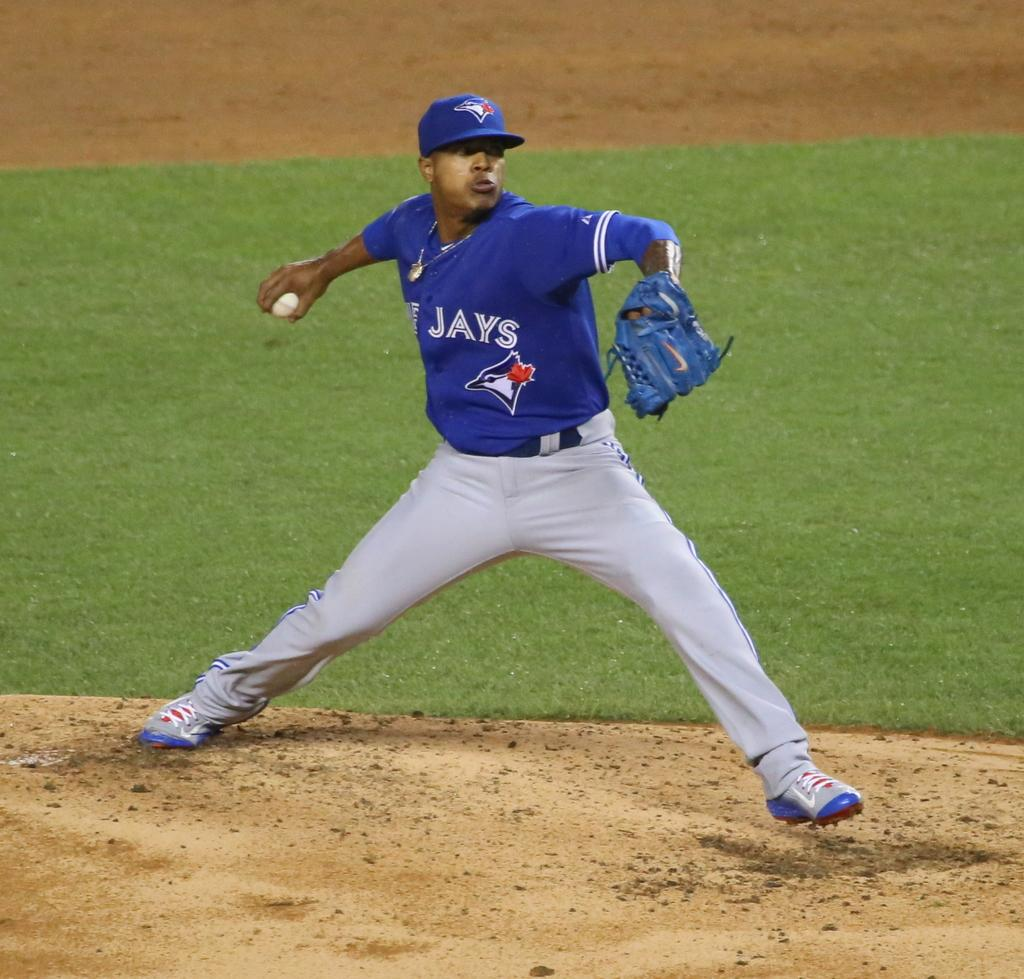Provide a one-sentence caption for the provided image. A Toronto Blue Jays pitcher prepares to throw a baseball. 